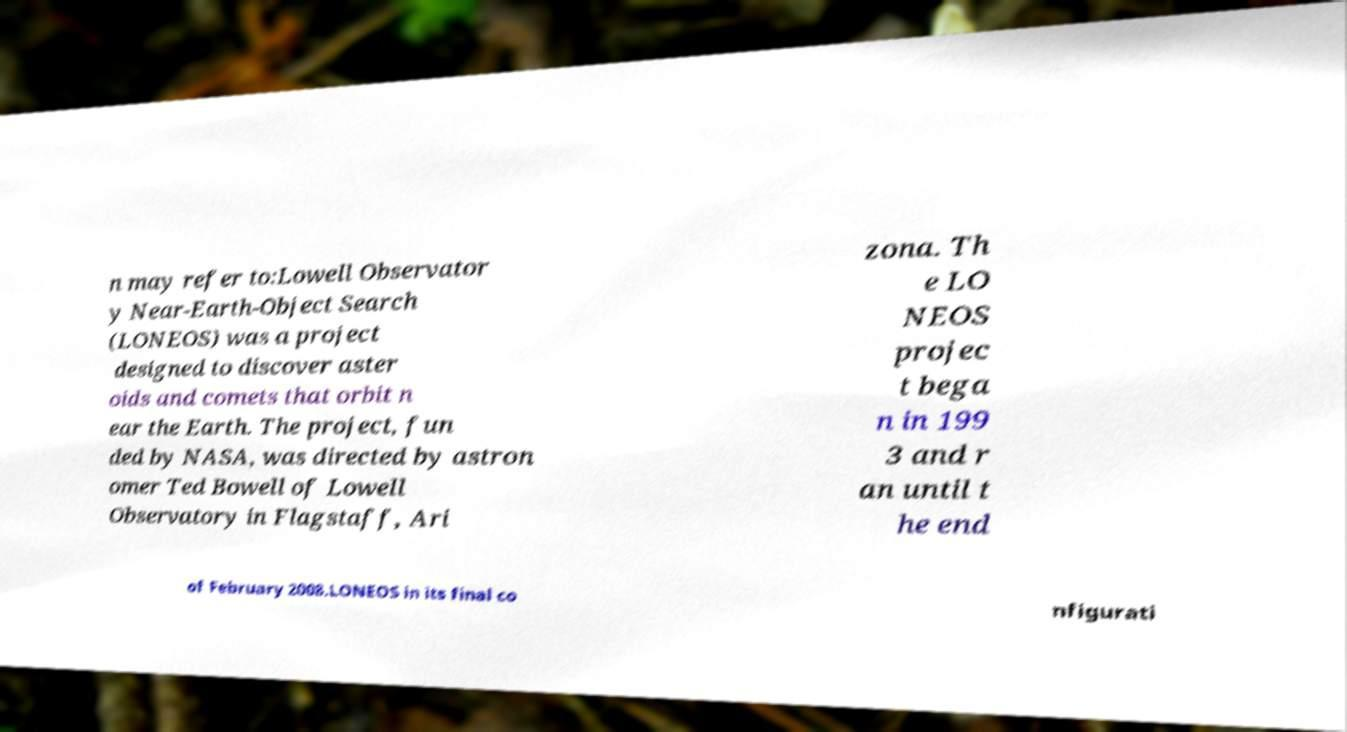Can you accurately transcribe the text from the provided image for me? n may refer to:Lowell Observator y Near-Earth-Object Search (LONEOS) was a project designed to discover aster oids and comets that orbit n ear the Earth. The project, fun ded by NASA, was directed by astron omer Ted Bowell of Lowell Observatory in Flagstaff, Ari zona. Th e LO NEOS projec t bega n in 199 3 and r an until t he end of February 2008.LONEOS in its final co nfigurati 